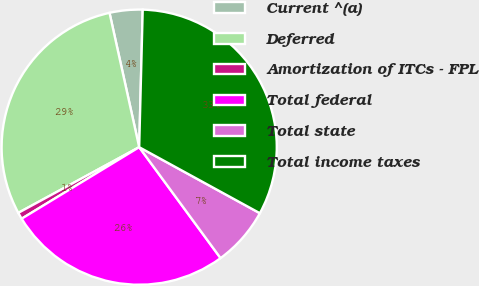Convert chart to OTSL. <chart><loc_0><loc_0><loc_500><loc_500><pie_chart><fcel>Current ^(a)<fcel>Deferred<fcel>Amortization of ITCs - FPL<fcel>Total federal<fcel>Total state<fcel>Total income taxes<nl><fcel>3.87%<fcel>29.46%<fcel>0.78%<fcel>26.37%<fcel>6.96%<fcel>32.56%<nl></chart> 